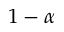<formula> <loc_0><loc_0><loc_500><loc_500>1 - \alpha</formula> 